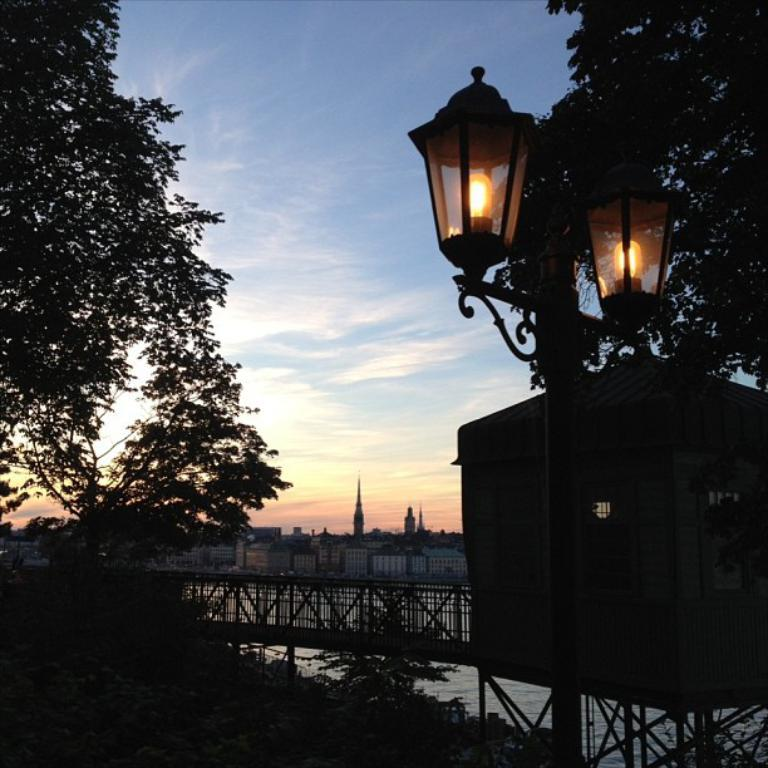What type of structure can be seen in the image? There is a bridge in the image. Are there any buildings or houses in the image? Yes, there is a house in the image. What can be seen illuminating the scene in the image? There are lights in the image. What type of natural environment is present in the image? There are many trees in the image. What body of water is visible in the image? There is water visible in the image. What can be seen in the background of the image? There are many buildings and clouds in the background of the image, and the sky is also visible. What type of bread is being used to paint the cast in the image? There is no bread, painting, or cast present in the image. 